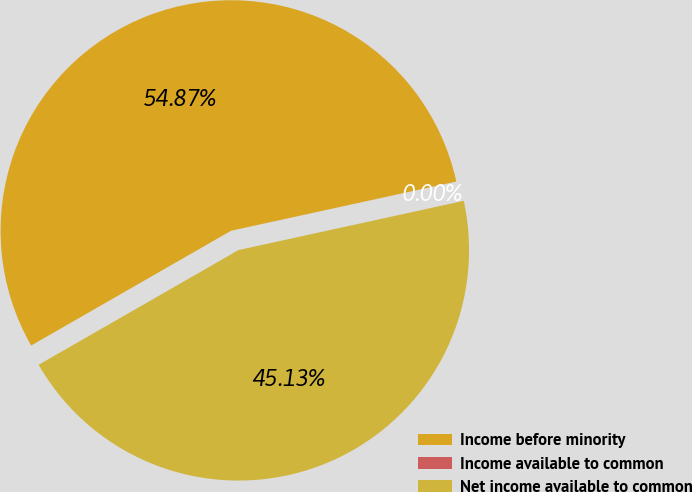Convert chart to OTSL. <chart><loc_0><loc_0><loc_500><loc_500><pie_chart><fcel>Income before minority<fcel>Income available to common<fcel>Net income available to common<nl><fcel>54.87%<fcel>0.0%<fcel>45.13%<nl></chart> 